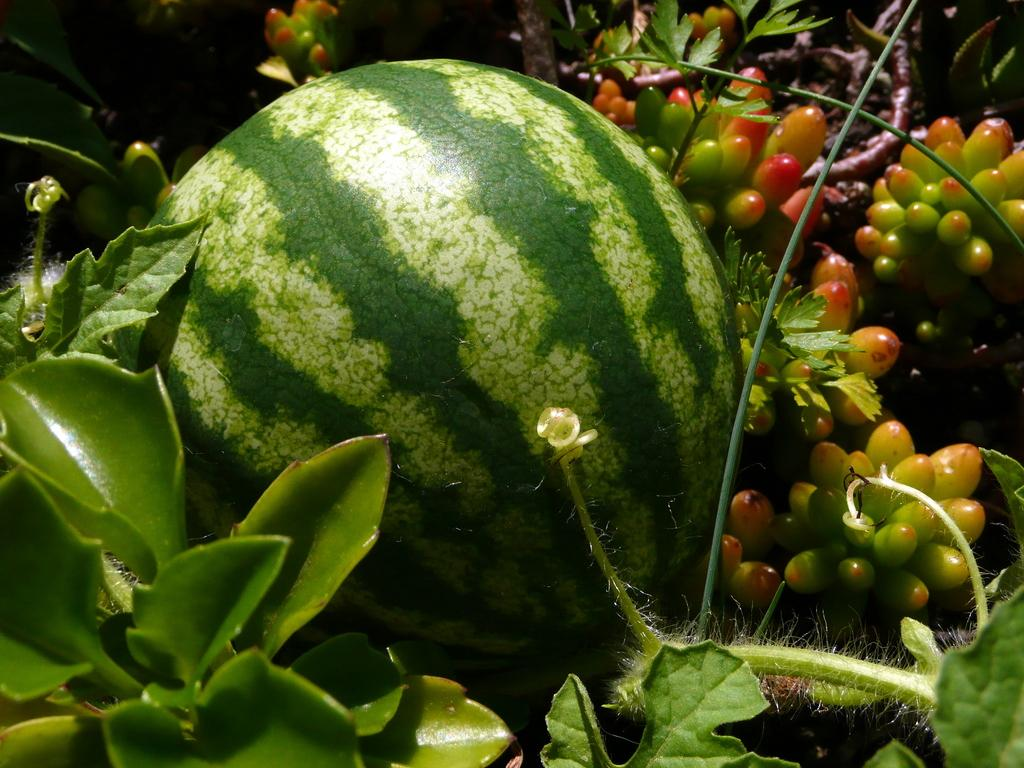What type of food can be seen in the image? There are fruits in the image. What else is present in the image besides the fruits? There are leaves in the image. What type of music can be heard playing in the background of the image? There is no music present in the image, as it only features fruits and leaves. 